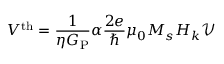<formula> <loc_0><loc_0><loc_500><loc_500>V ^ { t h } = \frac { 1 } { \eta G _ { P } } \alpha \frac { 2 e } { } \mu _ { 0 } M _ { s } H _ { k } \mathcal { V }</formula> 